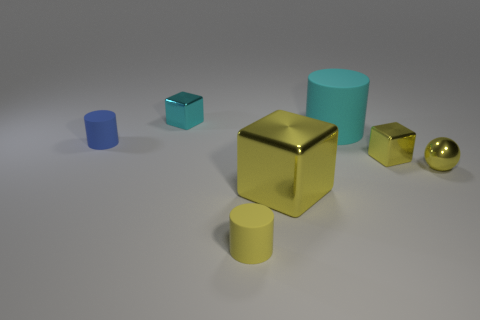Apart from the cylinders, what other shapes can be seen in the image, and what colors are they? Apart from the cylinders, the image showcases a variety of geometric shapes. There's a reflective gold cube at the center, a teal cube to the far left, and a small golden sphere to the right. These shapes add a diverse textural contrast to the scene. 